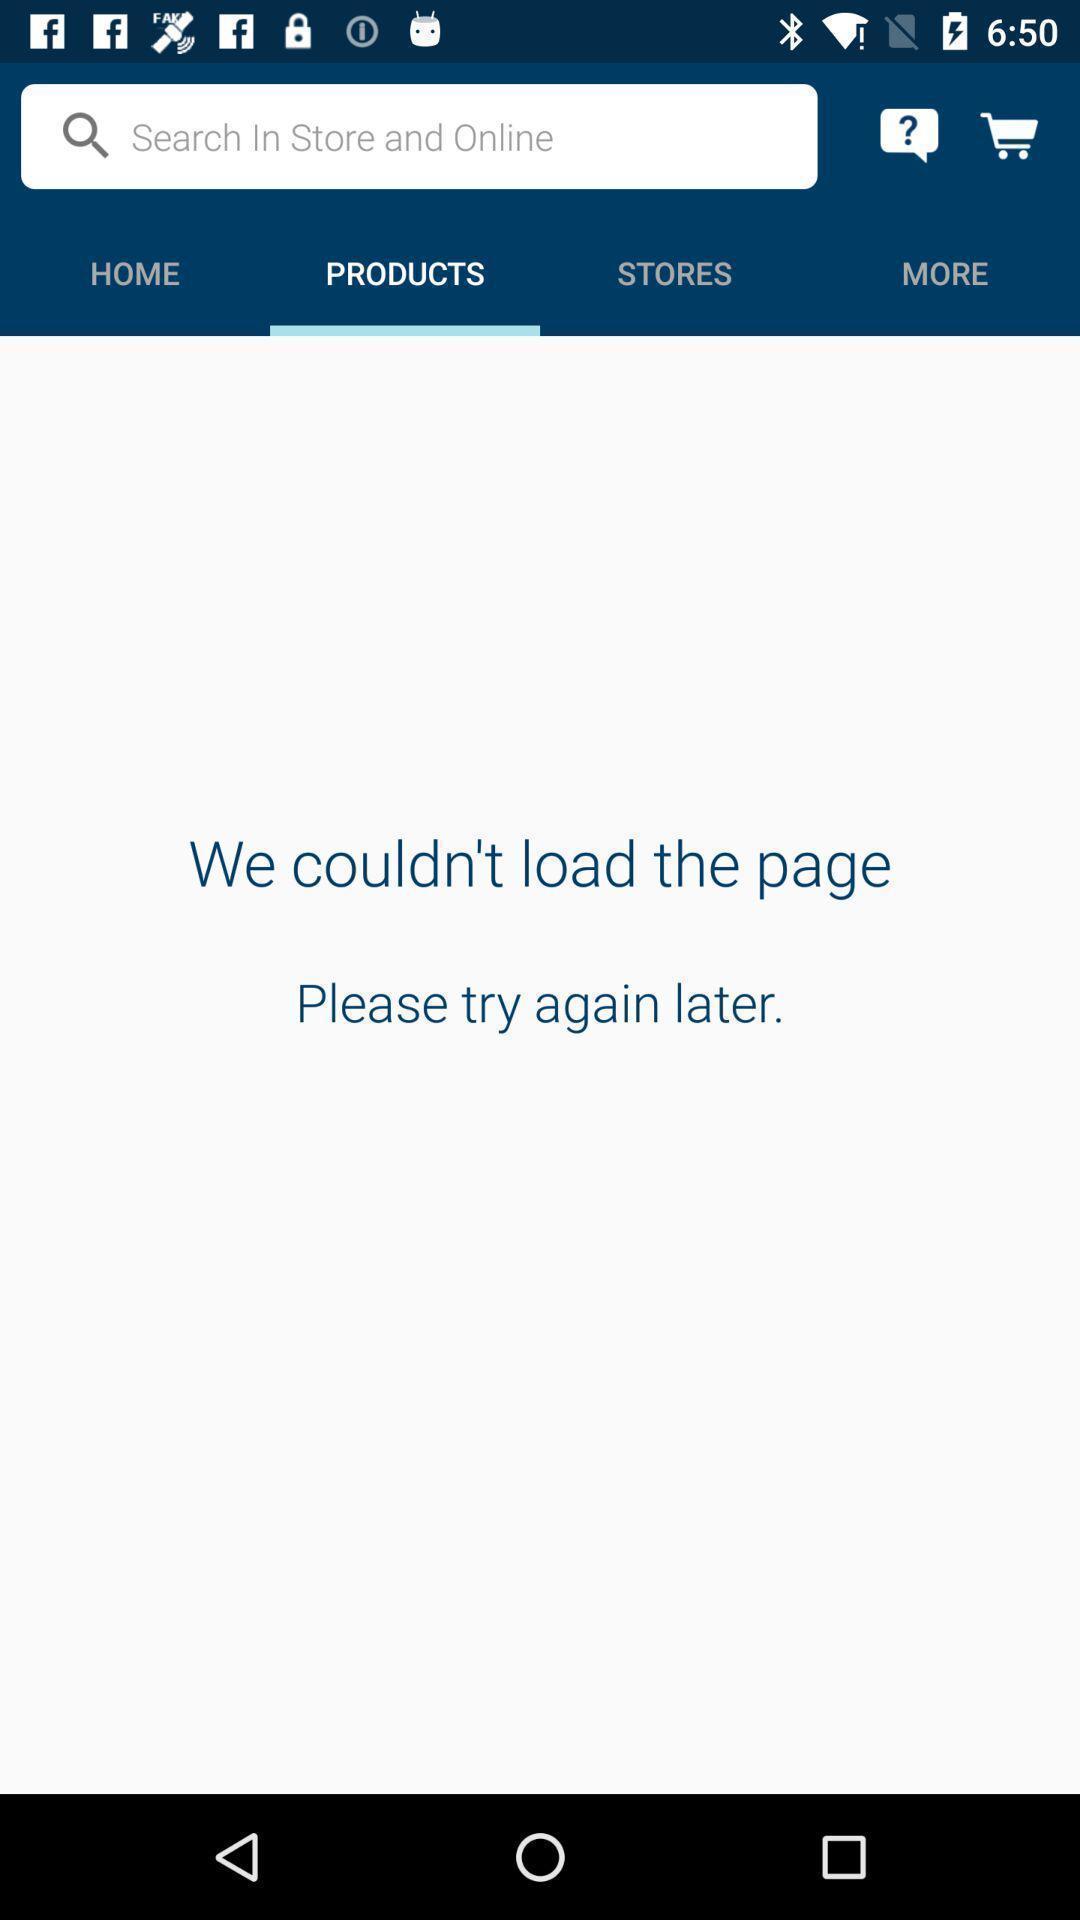Provide a textual representation of this image. Search page for searching products in shopping app. 